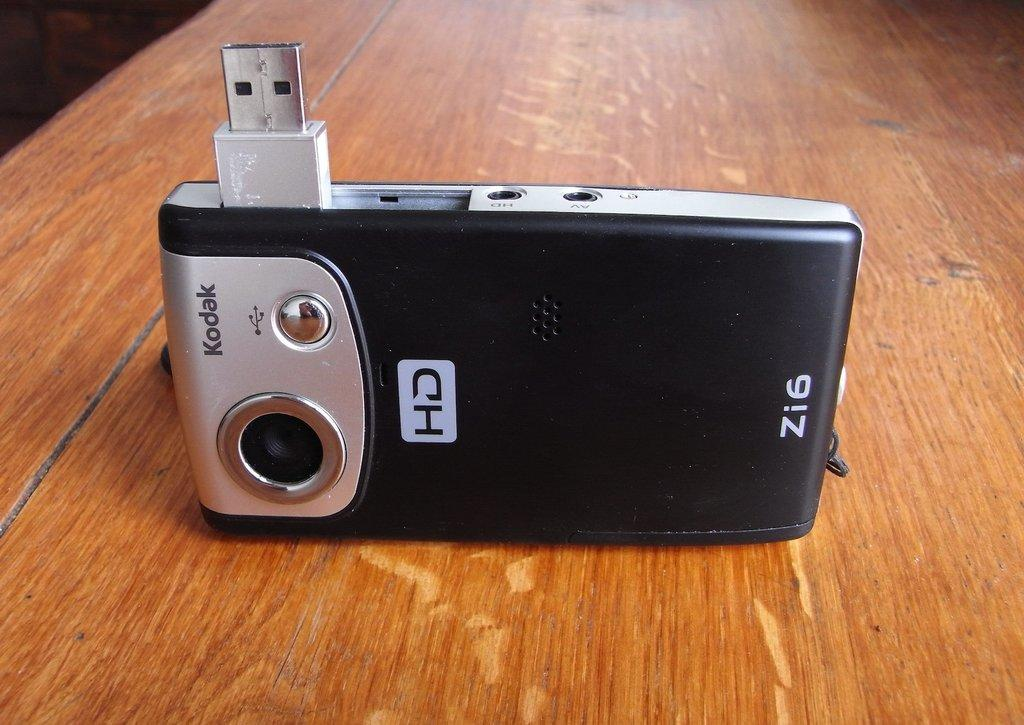What piece of furniture is present in the image? There is a table in the image. What object can be seen on the table? There is an electronic device on the table. What type of toothbrush is visible in the image? There is no toothbrush present in the image. What kind of powder can be seen on the electronic device in the image? There is no powder visible on the electronic device in the image. 